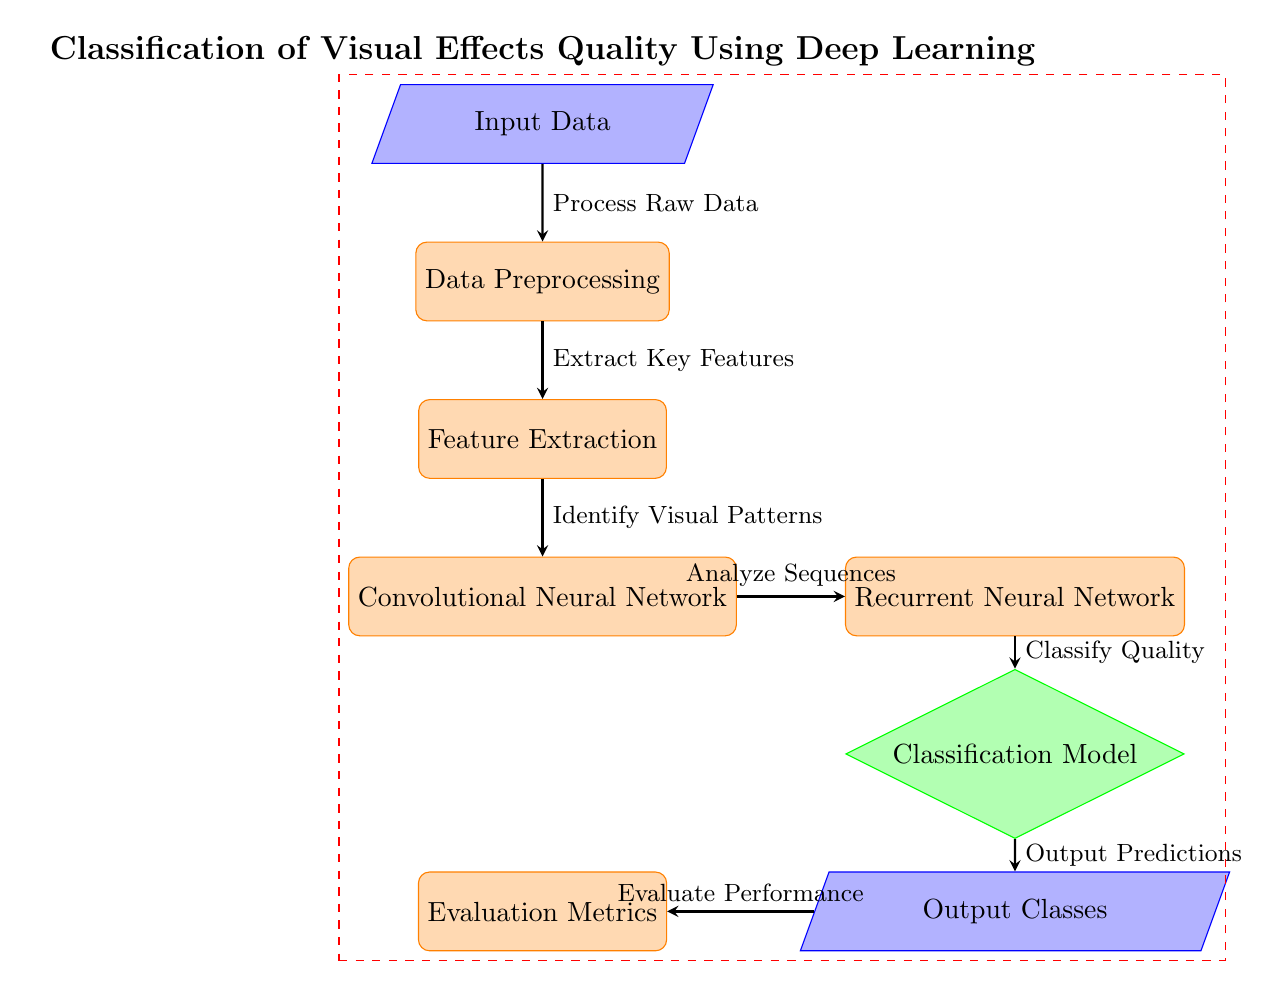What is the first step in this diagram? The first node is "Input Data." This can be easily identified as it is at the top of the diagram before any processing steps take place.
Answer: Input Data How many processes are depicted in the diagram? There are five process nodes shown in the diagram: Data Preprocessing, Feature Extraction, Convolutional Neural Network, Recurrent Neural Network, and Evaluation Metrics. Counting these nodes gives the total.
Answer: Five What does the "Recurrent Neural Network" node do? The "Recurrent Neural Network" node is connected by an arrow labeled "Analyze Sequences," indicating that it processes information to analyze sequences of data implemented in the pipeline.
Answer: Analyze Sequences What is the final output of the classification model? The output from the diagram is labeled as "Output Classes," indicating that after classification processing, this node represents the final classes that result from the analysis.
Answer: Output Classes What type of model follows the "Feature Extraction"? The model that follows the "Feature Extraction" node is the "Convolutional Neural Network," as shown by the direct downward arrow connecting these two nodes in the flowchart.
Answer: Convolutional Neural Network What are the evaluation metrics used for in this process? The node labeled "Evaluation Metrics" is reached after the "Output Classes," which illustrates its role in assessing the performance of the classification model, hence providing feedback on effectiveness.
Answer: Evaluate Performance What two main types of neural networks are utilized in this classification process? The diagram includes two types of neural networks: the "Convolutional Neural Network" and the "Recurrent Neural Network," as indicated by their respective nodes connected sequentially.
Answer: Convolutional Neural Network, Recurrent Neural Network At which step does the classification of quality occur? The classification occurs at the "Classification Model" node, where the flow indicates that this is the precise point where the quality of the visual effects is classified.
Answer: Classification Model 